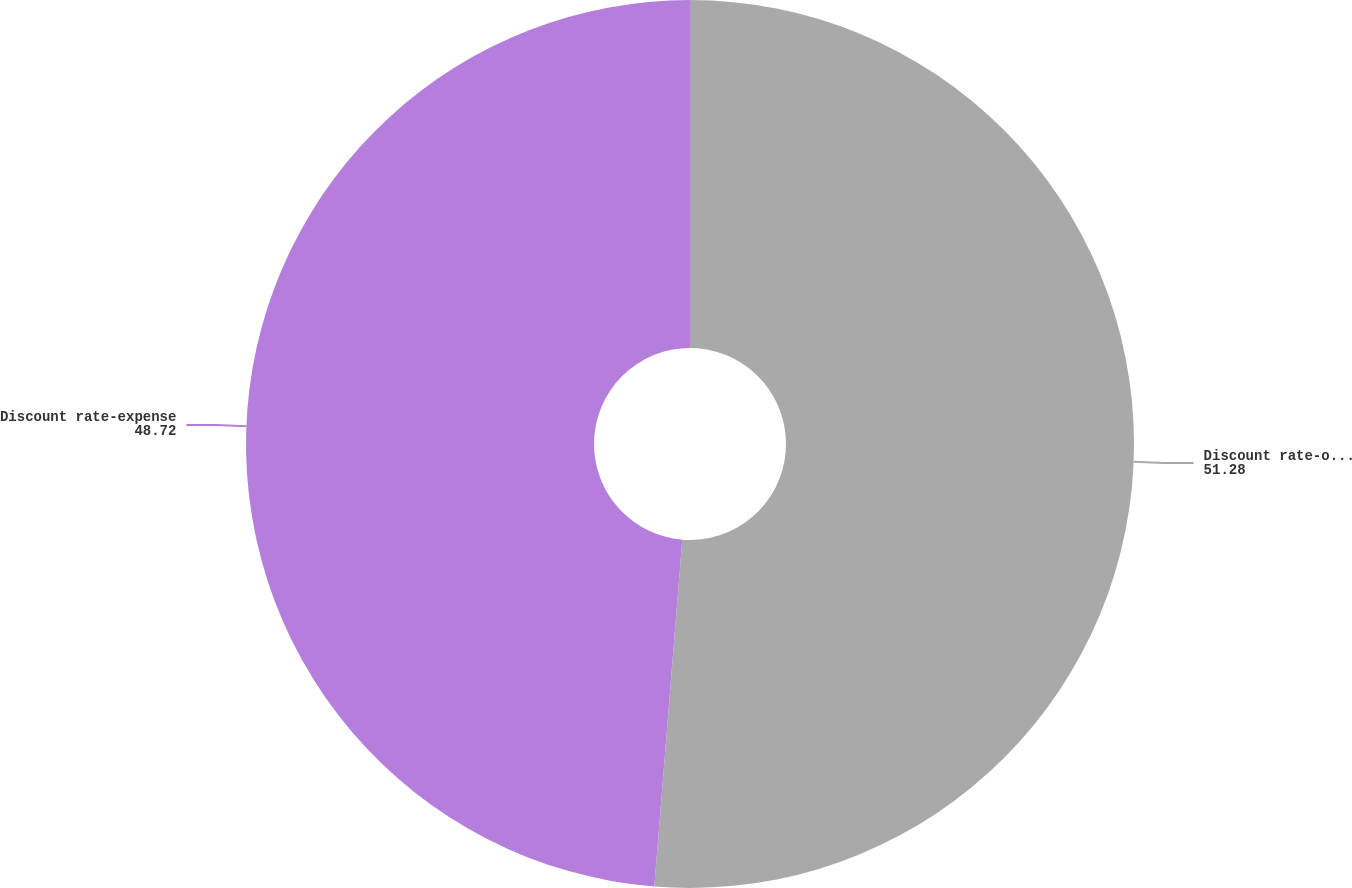Convert chart to OTSL. <chart><loc_0><loc_0><loc_500><loc_500><pie_chart><fcel>Discount rate-obligation<fcel>Discount rate-expense<nl><fcel>51.28%<fcel>48.72%<nl></chart> 